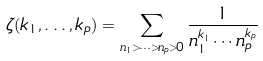Convert formula to latex. <formula><loc_0><loc_0><loc_500><loc_500>\zeta ( k _ { 1 } , \dots , k _ { p } ) = \sum _ { n _ { 1 } > \cdots > n _ { p } > 0 } \frac { 1 } { n _ { 1 } ^ { k _ { 1 } } \cdots n _ { p } ^ { k _ { p } } }</formula> 